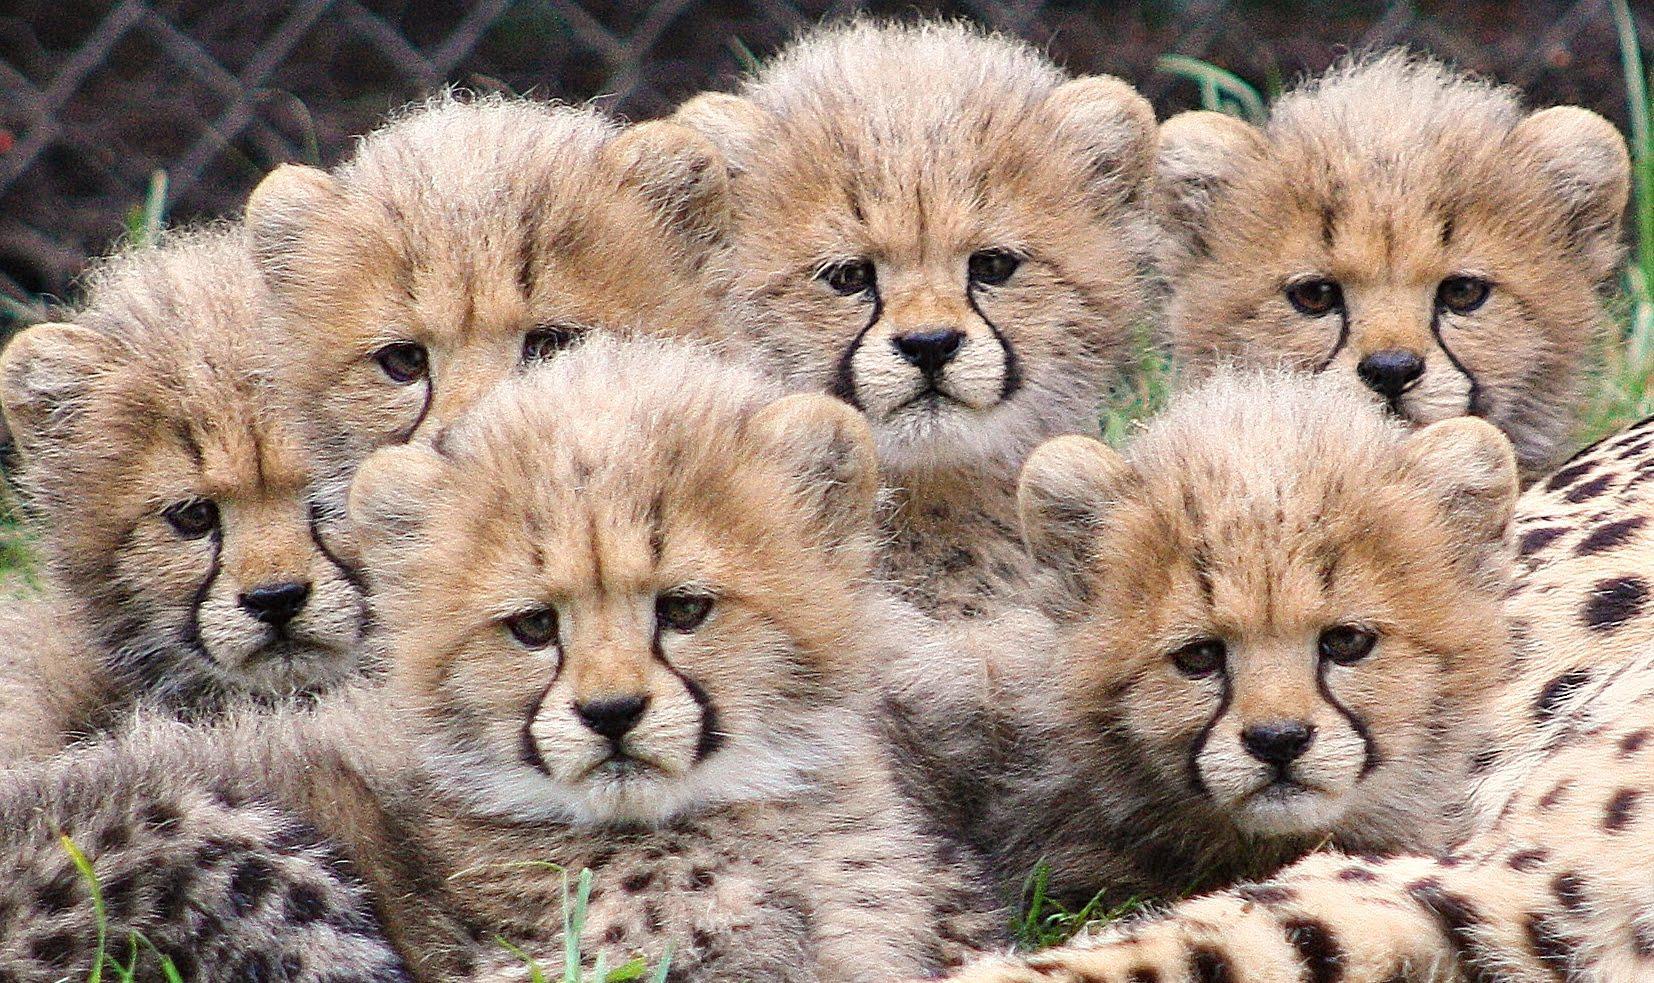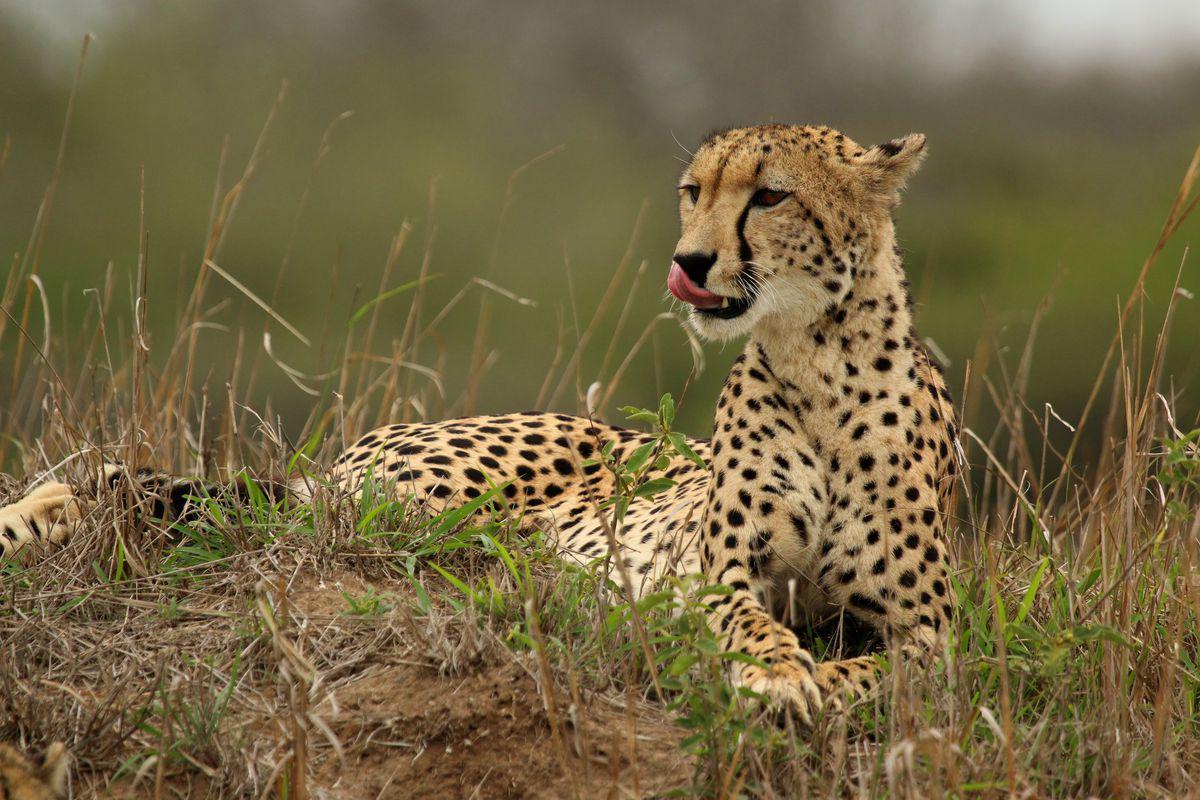The first image is the image on the left, the second image is the image on the right. Evaluate the accuracy of this statement regarding the images: "An image contains exactly one cheetah.". Is it true? Answer yes or no. Yes. The first image is the image on the left, the second image is the image on the right. Assess this claim about the two images: "The combined images include at least one adult cheetah and at least six fuzzy-headed baby cheetahs.". Correct or not? Answer yes or no. Yes. 